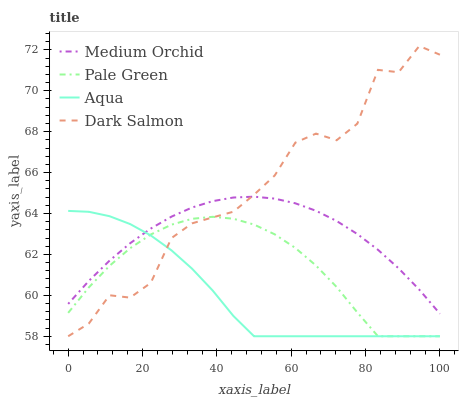Does Aqua have the minimum area under the curve?
Answer yes or no. Yes. Does Medium Orchid have the minimum area under the curve?
Answer yes or no. No. Does Medium Orchid have the maximum area under the curve?
Answer yes or no. No. Is Aqua the smoothest?
Answer yes or no. No. Is Aqua the roughest?
Answer yes or no. No. Does Medium Orchid have the lowest value?
Answer yes or no. No. Does Medium Orchid have the highest value?
Answer yes or no. No. Is Pale Green less than Medium Orchid?
Answer yes or no. Yes. Is Medium Orchid greater than Pale Green?
Answer yes or no. Yes. Does Pale Green intersect Medium Orchid?
Answer yes or no. No. 